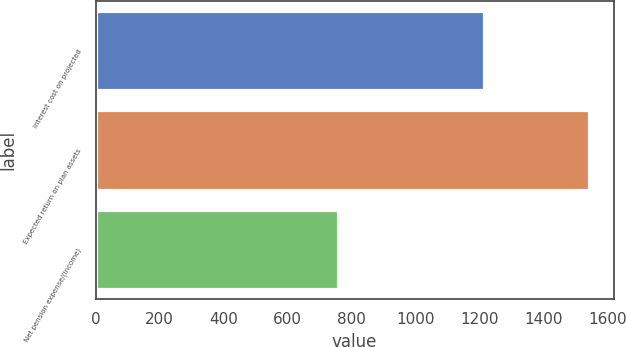Convert chart to OTSL. <chart><loc_0><loc_0><loc_500><loc_500><bar_chart><fcel>Interest cost on projected<fcel>Expected return on plan assets<fcel>Net pension expense/(income)<nl><fcel>1213<fcel>1542<fcel>759<nl></chart> 